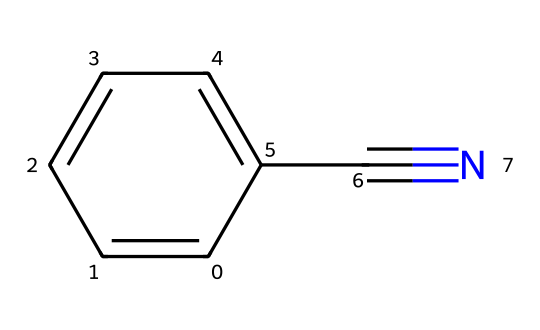What is the common name of this chemical? The SMILES representation c1ccccc1C#N indicates a benzene ring (c1ccccc1) attached to a nitrile group (C#N). The common name for this structure is benzonitrile.
Answer: benzonitrile How many carbon atoms are in benzonitrile? By analyzing the SMILES, we see there are six carbon atoms in the benzene ring and one carbon atom in the nitrile group, totaling seven carbon atoms.
Answer: 7 What type of functional group is present in benzonitrile? The presence of the C#N bond in the chemical structure indicates a nitrile functional group. This is characteristic of compounds like benzonitrile.
Answer: nitrile What is the total number of hydrogen atoms in benzonitrile? The benzene ring contributes five hydrogen atoms (one is replaced by the nitrile group), leading to a total of five hydrogen atoms in benzonitrile.
Answer: 5 What is the characteristic feature of nitriles seen in benzonitrile's structure? The defining characteristic of nitriles is the presence of the triple bond between carbon and nitrogen, which is represented as C#N in the structure of benzonitrile.
Answer: C#N Why might benzonitrile be used in automotive paint? Benzonitrile's aromatic structure and nitrile group contribute to its solvency and adhesion properties, making it suitable for use in paints and coatings that require durability and gloss.
Answer: solvency and adhesion properties 